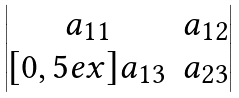<formula> <loc_0><loc_0><loc_500><loc_500>\begin{vmatrix} a _ { 1 1 } & a _ { 1 2 } \\ [ 0 , 5 e x ] a _ { 1 3 } & a _ { 2 3 } \end{vmatrix}</formula> 